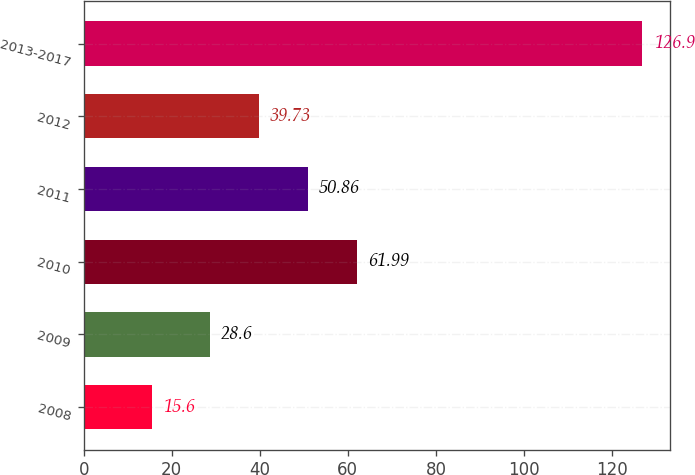Convert chart. <chart><loc_0><loc_0><loc_500><loc_500><bar_chart><fcel>2008<fcel>2009<fcel>2010<fcel>2011<fcel>2012<fcel>2013-2017<nl><fcel>15.6<fcel>28.6<fcel>61.99<fcel>50.86<fcel>39.73<fcel>126.9<nl></chart> 